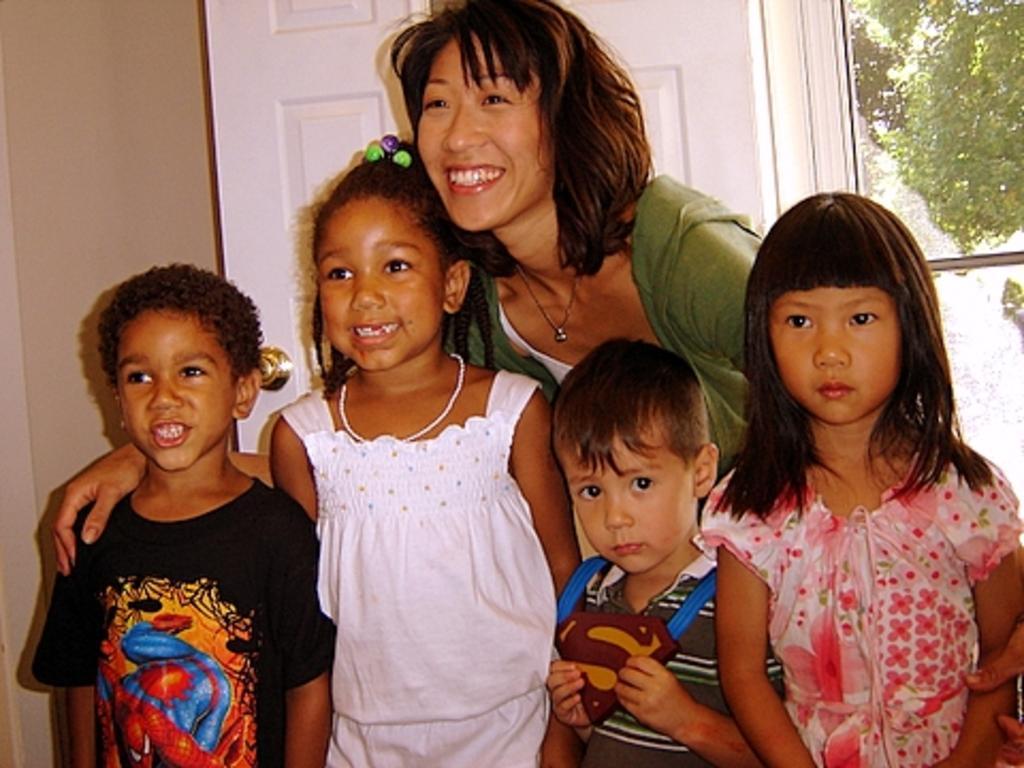Can you describe this image briefly? In this picture I can observe woman and four children. Some of them are smiling. Behind the woman I can observe door. On the right side I can observe trees. 